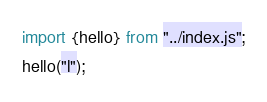Convert code to text. <code><loc_0><loc_0><loc_500><loc_500><_JavaScript_>import {hello} from "../index.js";
hello("l");</code> 